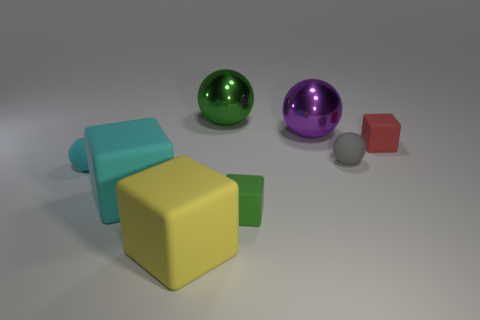Subtract all small gray matte spheres. How many spheres are left? 3 Add 2 tiny red shiny cylinders. How many objects exist? 10 Subtract all cyan cubes. How many cubes are left? 3 Subtract 1 balls. How many balls are left? 3 Subtract all blue spheres. Subtract all blue cubes. How many spheres are left? 4 Subtract all cyan cylinders. How many yellow blocks are left? 1 Subtract all green matte cylinders. Subtract all gray things. How many objects are left? 7 Add 5 yellow objects. How many yellow objects are left? 6 Add 4 small red blocks. How many small red blocks exist? 5 Subtract 0 brown blocks. How many objects are left? 8 